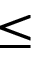Convert formula to latex. <formula><loc_0><loc_0><loc_500><loc_500>\leq</formula> 